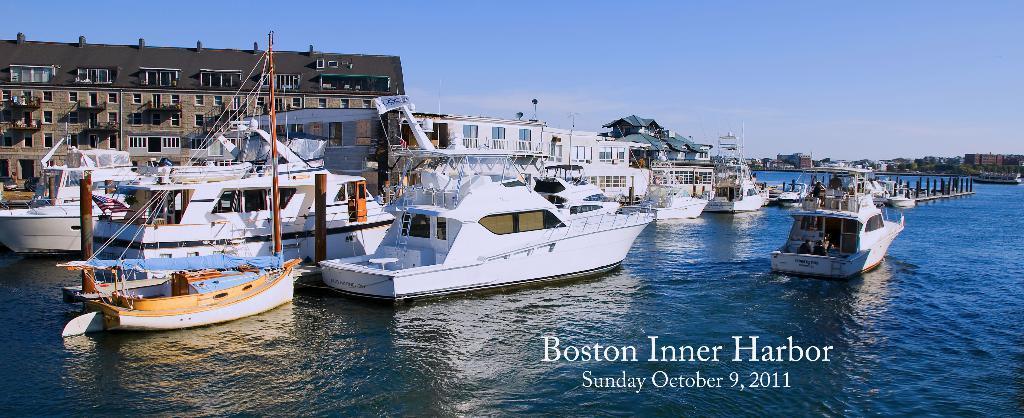Please provide a concise description of this image. In the center of the image we can see ships on the ocean. In the background we can see poles, building, vehicles, trees, water, ships, sky and clouds. 